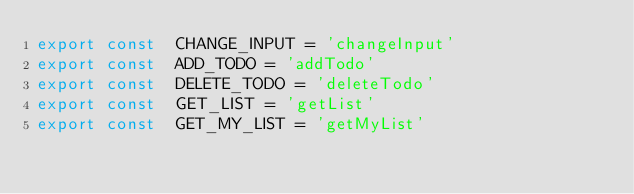Convert code to text. <code><loc_0><loc_0><loc_500><loc_500><_JavaScript_>export const  CHANGE_INPUT = 'changeInput'
export const  ADD_TODO = 'addTodo'
export const  DELETE_TODO = 'deleteTodo'
export const  GET_LIST = 'getList'
export const  GET_MY_LIST = 'getMyList'
</code> 